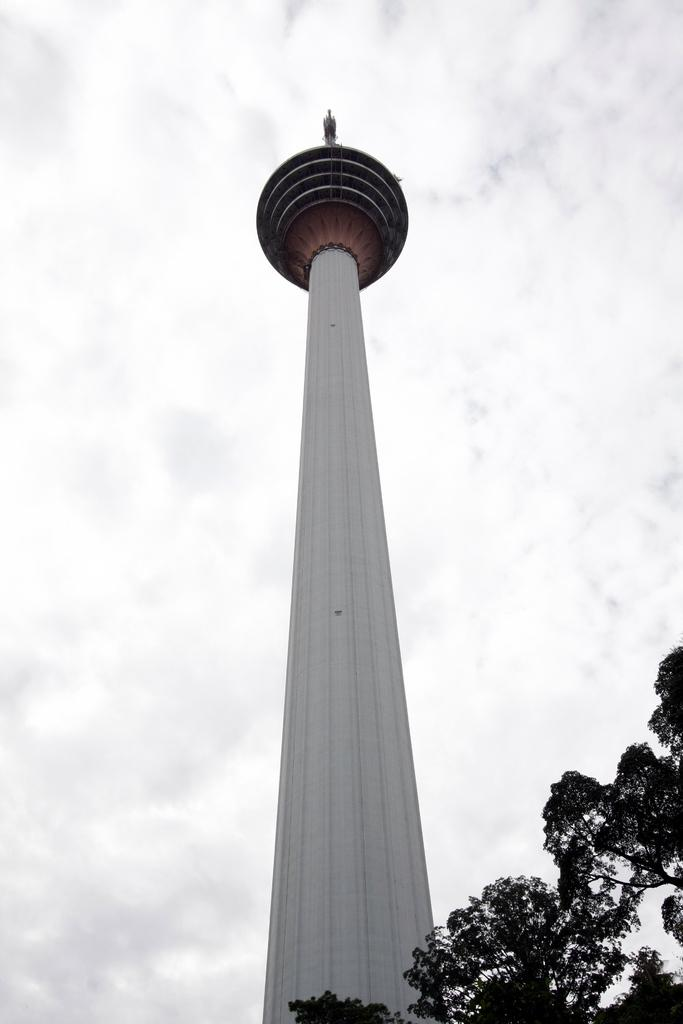What is the main structure in the center of the image? There is a tower in the center of the image. What type of vegetation is on the right side of the image? There is a tree on the right side of the image. What can be seen in the background of the image? The sky is visible in the background of the image. What type of pencil can be seen in the image? There is no pencil present in the image. Is there a ship visible in the image? No, there is no ship visible in the image. 